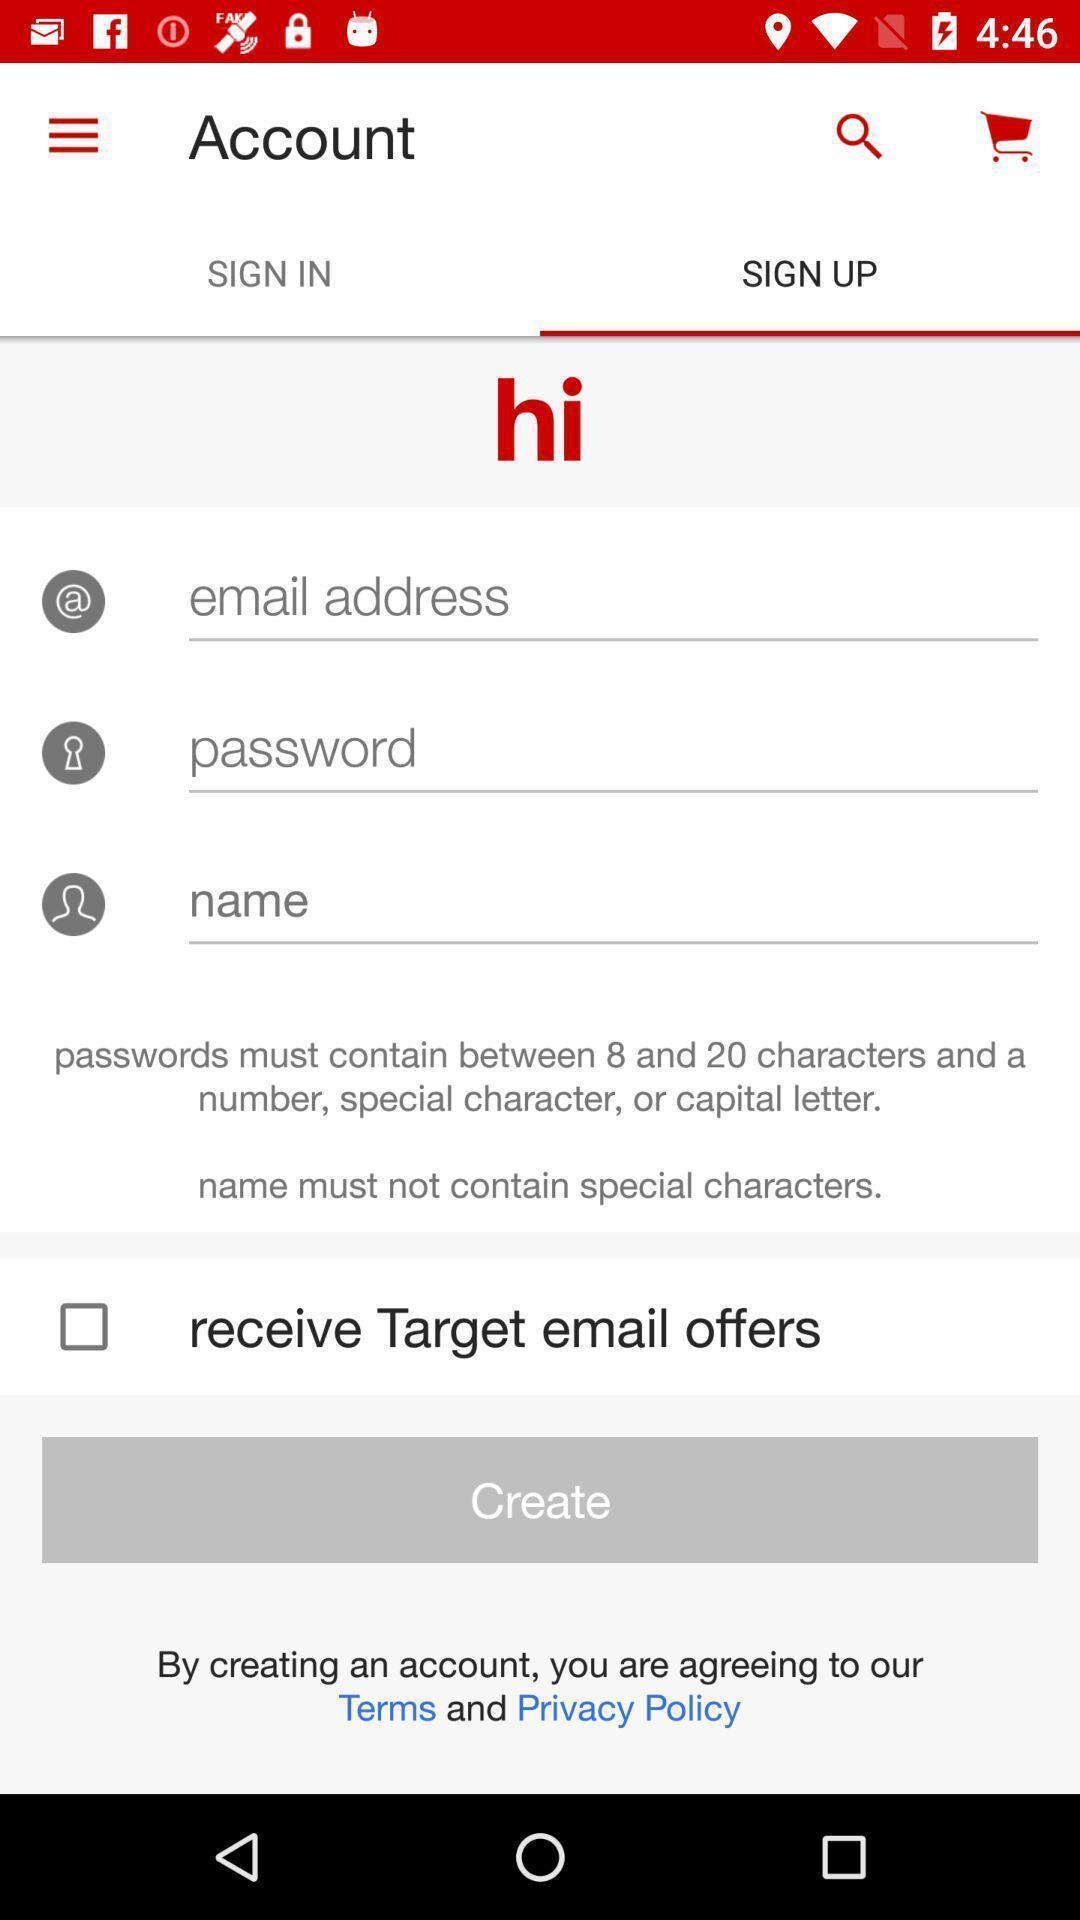Summarize the main components in this picture. Sign up page to create an account. 